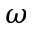Convert formula to latex. <formula><loc_0><loc_0><loc_500><loc_500>\omega</formula> 